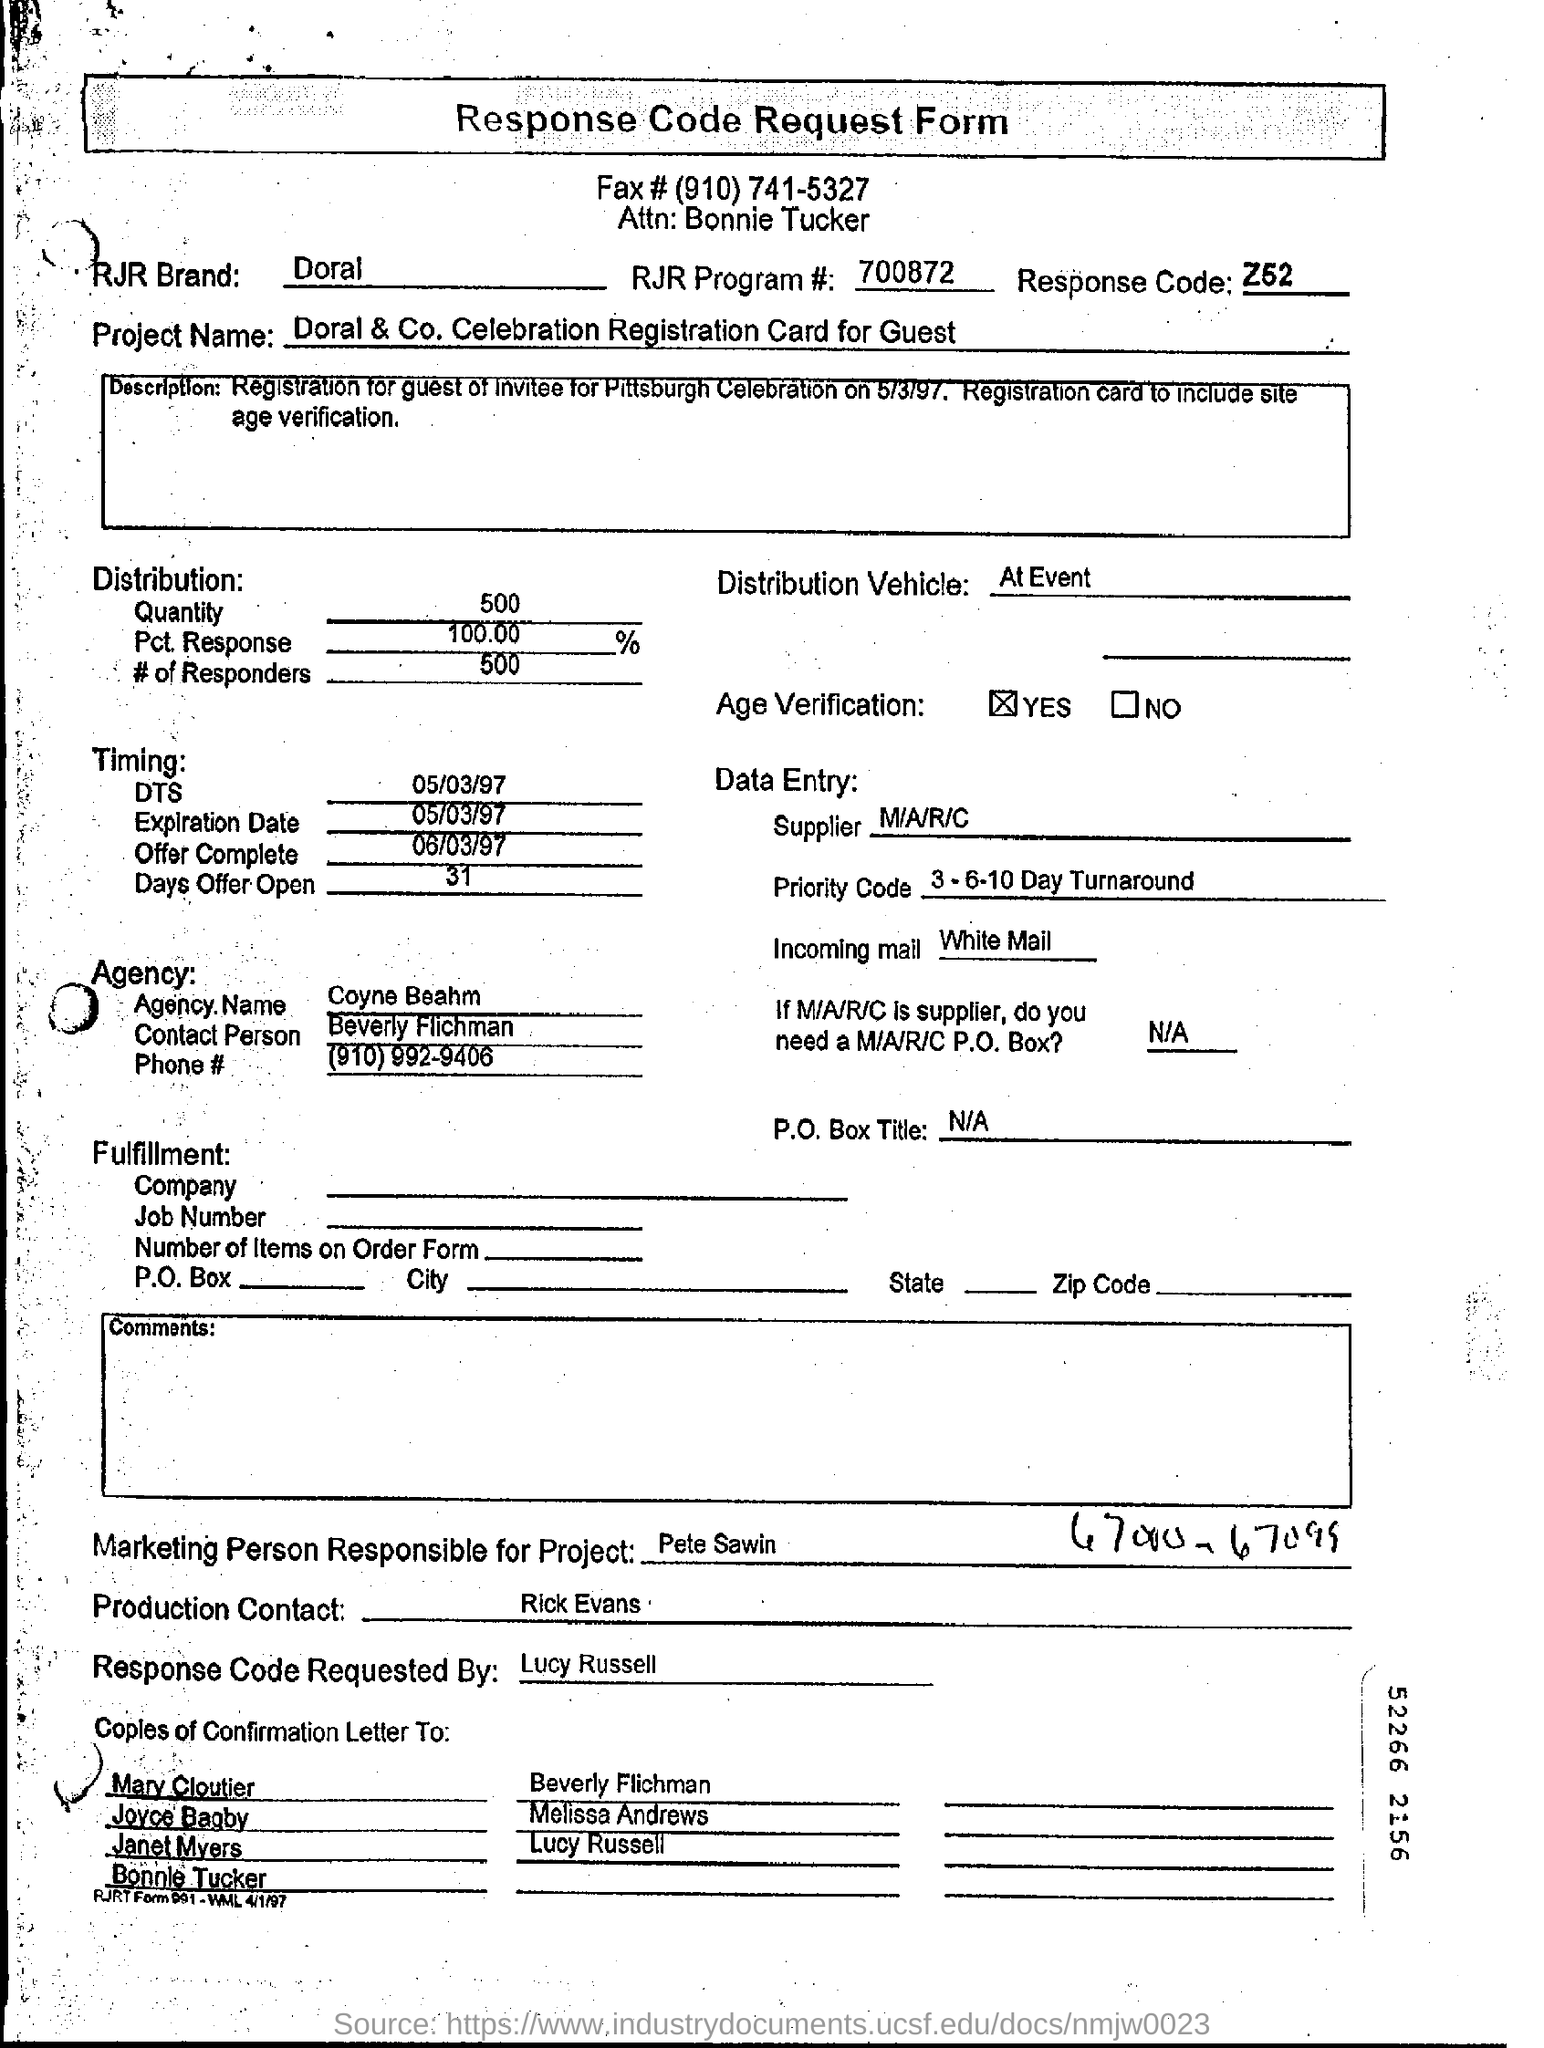What is the RJR Brand mentioned on the response code request form?
Keep it short and to the point. Doral. What is the response code mentioned on the form?
Your answer should be very brief. Z52. How much quantity is distributed?
Your response must be concise. 500. When will the offer expire?
Make the answer very short. 05/03/97. When will the offer complete?
Your answer should be very brief. 06/03/97. Who is the marketing person responsible for the project?
Keep it short and to the point. Pete Sawin. Who requested the response code request form?
Your response must be concise. Lucy Russell. 